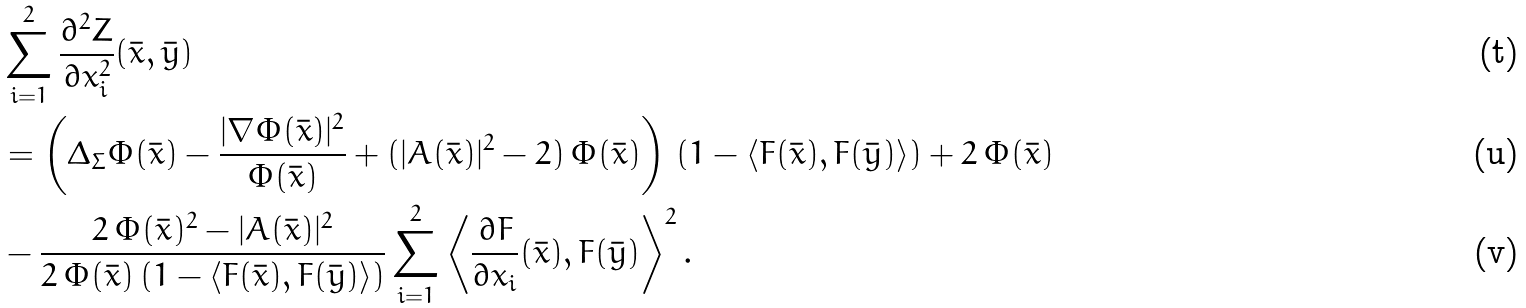Convert formula to latex. <formula><loc_0><loc_0><loc_500><loc_500>& \sum _ { i = 1 } ^ { 2 } \frac { \partial ^ { 2 } Z } { \partial x _ { i } ^ { 2 } } ( \bar { x } , \bar { y } ) \\ & = \left ( \Delta _ { \Sigma } \Phi ( \bar { x } ) - \frac { | \nabla \Phi ( \bar { x } ) | ^ { 2 } } { \Phi ( \bar { x } ) } + ( | A ( \bar { x } ) | ^ { 2 } - 2 ) \, \Phi ( \bar { x } ) \right ) \, ( 1 - \langle F ( \bar { x } ) , F ( \bar { y } ) \rangle ) + 2 \, \Phi ( \bar { x } ) \\ & - \frac { 2 \, \Phi ( \bar { x } ) ^ { 2 } - | A ( \bar { x } ) | ^ { 2 } } { 2 \, \Phi ( \bar { x } ) \, ( 1 - \langle F ( \bar { x } ) , F ( \bar { y } ) \rangle ) } \sum _ { i = 1 } ^ { 2 } \left \langle \frac { \partial F } { \partial x _ { i } } ( \bar { x } ) , F ( \bar { y } ) \right \rangle ^ { 2 } .</formula> 